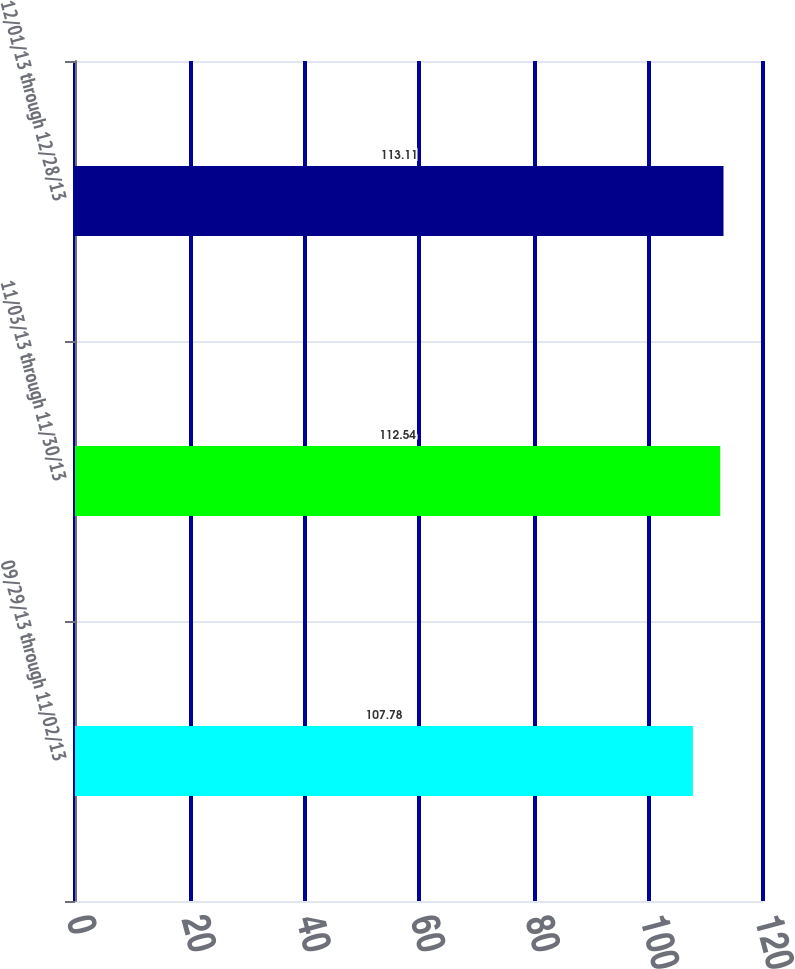Convert chart to OTSL. <chart><loc_0><loc_0><loc_500><loc_500><bar_chart><fcel>09/29/13 through 11/02/13<fcel>11/03/13 through 11/30/13<fcel>12/01/13 through 12/28/13<nl><fcel>107.78<fcel>112.54<fcel>113.11<nl></chart> 